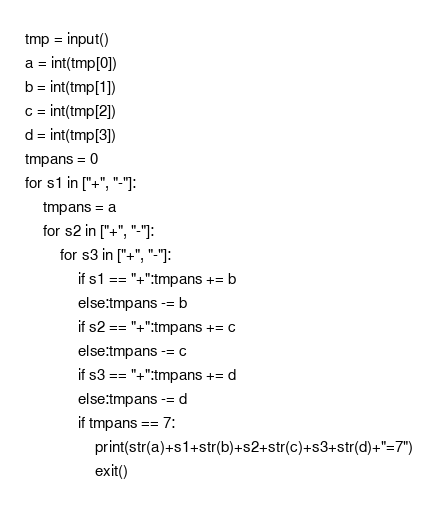Convert code to text. <code><loc_0><loc_0><loc_500><loc_500><_Python_>tmp = input()
a = int(tmp[0])
b = int(tmp[1])
c = int(tmp[2])
d = int(tmp[3])
tmpans = 0
for s1 in ["+", "-"]:
    tmpans = a
    for s2 in ["+", "-"]:
        for s3 in ["+", "-"]:
            if s1 == "+":tmpans += b
            else:tmpans -= b
            if s2 == "+":tmpans += c
            else:tmpans -= c
            if s3 == "+":tmpans += d
            else:tmpans -= d
            if tmpans == 7:
                print(str(a)+s1+str(b)+s2+str(c)+s3+str(d)+"=7")
                exit()

</code> 